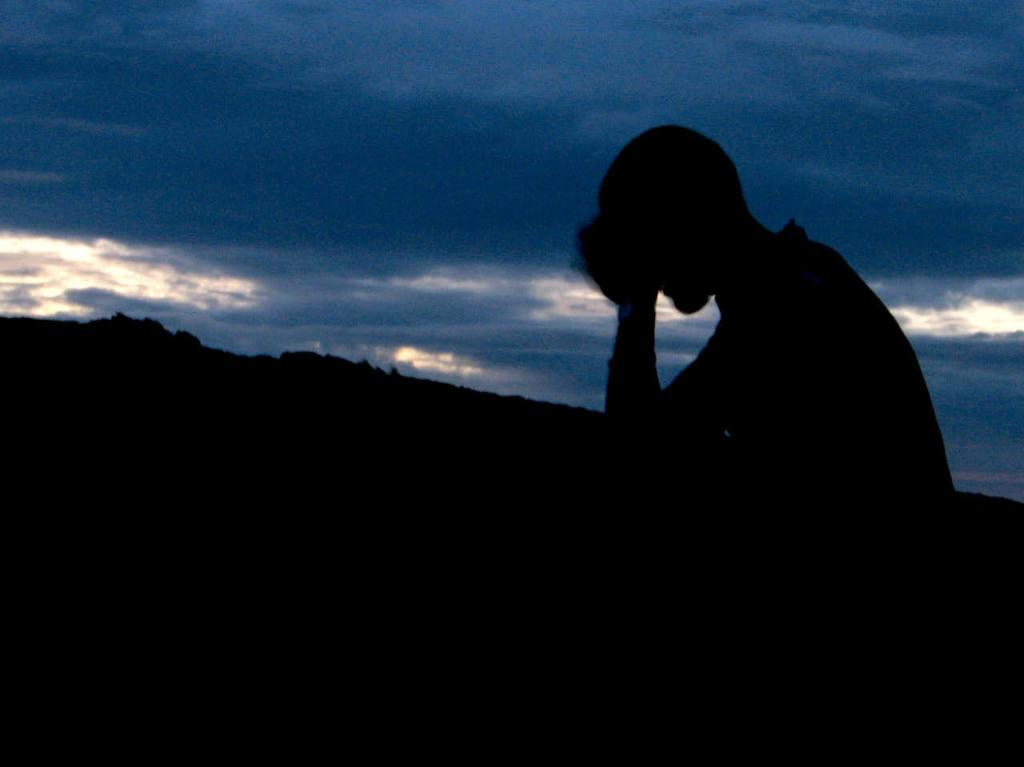Who or what is located on the right side of the image? There is a person on the right side of the image. What type of natural feature can be seen in the middle of the image? Hills are present in the middle of the image. What is visible in the sky at the top of the image? Clouds are visible in the sky at the top of the image. How many gallons of milk can be seen on the edge of the image? There is no milk present in the image, so it is not possible to determine the quantity or location of any milk. 